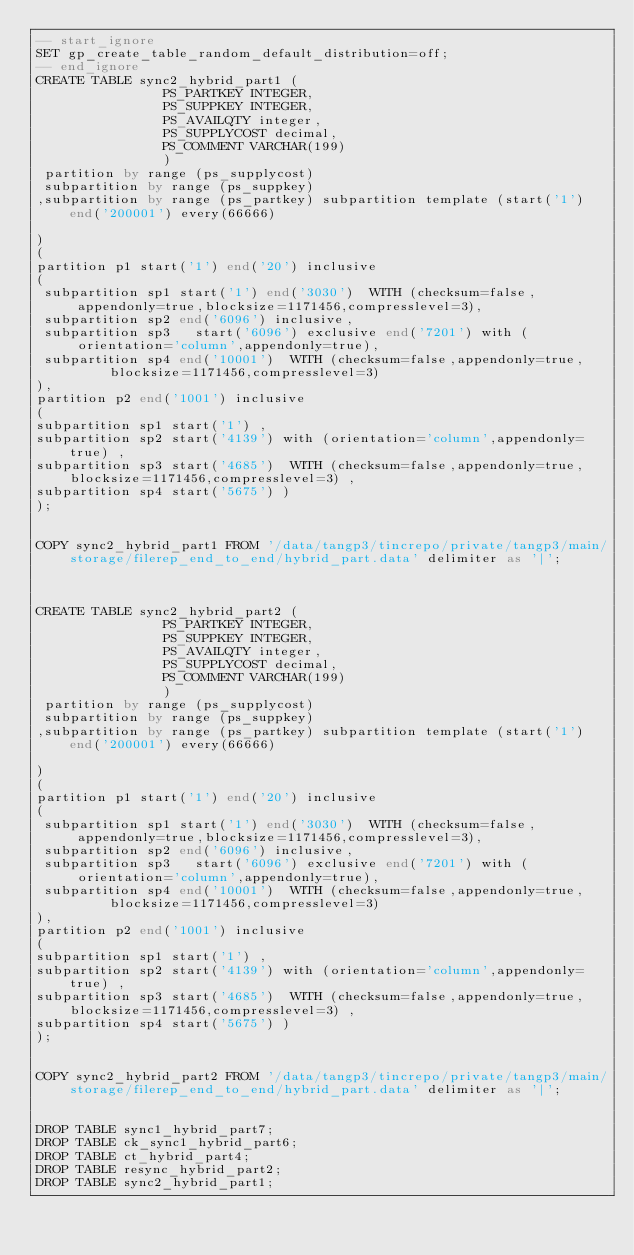<code> <loc_0><loc_0><loc_500><loc_500><_SQL_>-- start_ignore
SET gp_create_table_random_default_distribution=off;
-- end_ignore
CREATE TABLE sync2_hybrid_part1 (
                PS_PARTKEY INTEGER,
                PS_SUPPKEY INTEGER,
                PS_AVAILQTY integer,
                PS_SUPPLYCOST decimal,
                PS_COMMENT VARCHAR(199)
                ) 
 partition by range (ps_supplycost)
 subpartition by range (ps_suppkey)
,subpartition by range (ps_partkey) subpartition template (start('1') end('200001') every(66666)

)
(
partition p1 start('1') end('20') inclusive
(
 subpartition sp1 start('1') end('3030')  WITH (checksum=false,   appendonly=true,blocksize=1171456,compresslevel=3),
 subpartition sp2 end('6096') inclusive,
 subpartition sp3   start('6096') exclusive end('7201') with (orientation='column',appendonly=true),
 subpartition sp4 end('10001')  WITH (checksum=false,appendonly=true,     blocksize=1171456,compresslevel=3)
), 
partition p2 end('1001') inclusive
(
subpartition sp1 start('1') ,        
subpartition sp2 start('4139') with (orientation='column',appendonly=true) ,
subpartition sp3 start('4685')  WITH (checksum=false,appendonly=true, blocksize=1171456,compresslevel=3) ,
subpartition sp4 start('5675') )
);


COPY sync2_hybrid_part1 FROM '/data/tangp3/tincrepo/private/tangp3/main/storage/filerep_end_to_end/hybrid_part.data' delimiter as '|';



CREATE TABLE sync2_hybrid_part2 (
                PS_PARTKEY INTEGER,
                PS_SUPPKEY INTEGER,
                PS_AVAILQTY integer,
                PS_SUPPLYCOST decimal,
                PS_COMMENT VARCHAR(199)
                ) 
 partition by range (ps_supplycost)
 subpartition by range (ps_suppkey)
,subpartition by range (ps_partkey) subpartition template (start('1') end('200001') every(66666)

)
(
partition p1 start('1') end('20') inclusive
(
 subpartition sp1 start('1') end('3030')  WITH (checksum=false,   appendonly=true,blocksize=1171456,compresslevel=3),
 subpartition sp2 end('6096') inclusive,
 subpartition sp3   start('6096') exclusive end('7201') with (orientation='column',appendonly=true),
 subpartition sp4 end('10001')  WITH (checksum=false,appendonly=true,     blocksize=1171456,compresslevel=3)
), 
partition p2 end('1001') inclusive
(
subpartition sp1 start('1') ,        
subpartition sp2 start('4139') with (orientation='column',appendonly=true) ,
subpartition sp3 start('4685')  WITH (checksum=false,appendonly=true, blocksize=1171456,compresslevel=3) ,
subpartition sp4 start('5675') )
);


COPY sync2_hybrid_part2 FROM '/data/tangp3/tincrepo/private/tangp3/main/storage/filerep_end_to_end/hybrid_part.data' delimiter as '|';


DROP TABLE sync1_hybrid_part7;
DROP TABLE ck_sync1_hybrid_part6;
DROP TABLE ct_hybrid_part4;
DROP TABLE resync_hybrid_part2;
DROP TABLE sync2_hybrid_part1;
</code> 